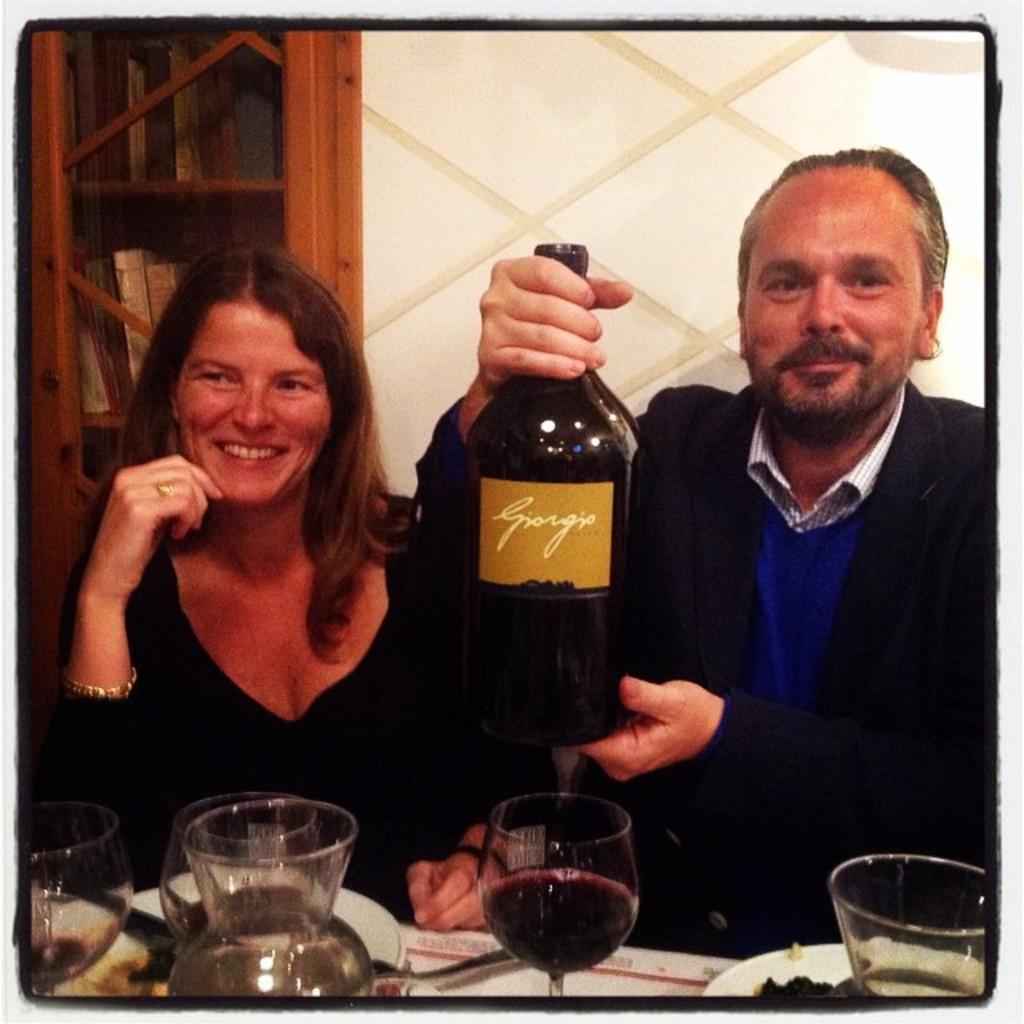Could you give a brief overview of what you see in this image? This picture shows a man and a woman seated and we see books in the bookshelf and we see man holding a wine bottle in his hand and we see few glasses and food in the plates on the table and we see a jug. 